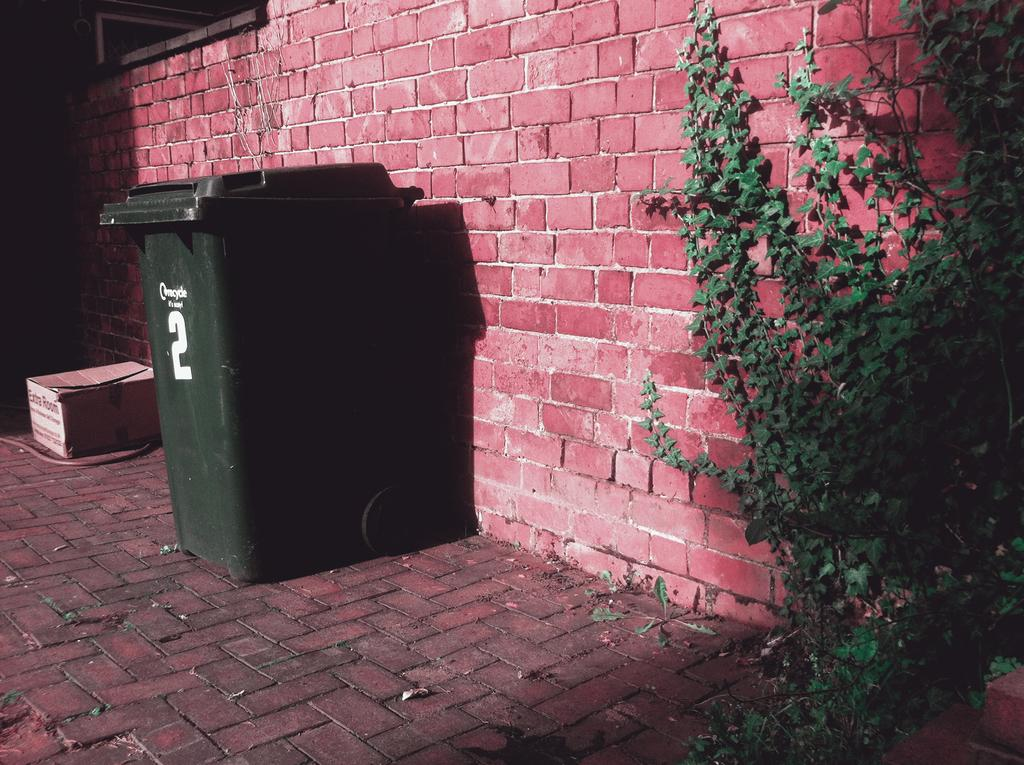Provide a one-sentence caption for the provided image. A green container with number 2 sits against a red brick wall. 